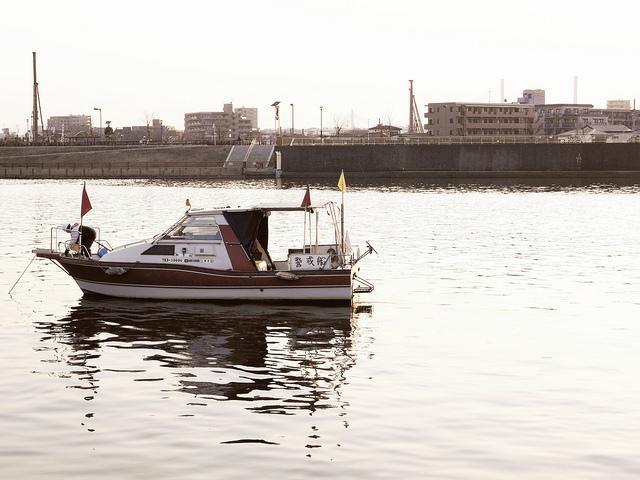How many different kinds of flags are posted on the boat?
Give a very brief answer. 3. 